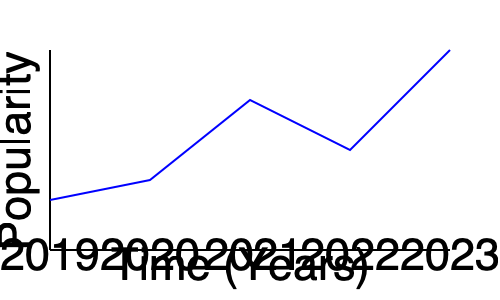Based on the line graph showing the trend of running-related article popularity from 2019 to 2023, which year would be the best time to introduce new types of running stories to broaden the magazine's audience? To determine the best year to introduce new types of running stories, we need to analyze the trend in the graph:

1. 2019 to 2020: There's a slight decrease in popularity.
2. 2020 to 2021: There's a significant increase in popularity.
3. 2021 to 2022: There's a moderate decrease in popularity.
4. 2022 to 2023: There's a sharp increase in popularity, reaching the highest point.

The best time to introduce new types of running stories would be when interest is high but starting to plateau or decline. This allows for capitalizing on the existing interest while providing fresh content to maintain engagement.

In this case, 2021 would be the ideal year because:
1. It follows a period of increased popularity (2020 to 2021).
2. It's just before a decline in interest (2021 to 2022).
3. Introducing new content at this point could help maintain the high interest and prevent the subsequent decline.

While 2023 shows the highest popularity, it might be too late to introduce new content types as the trend is already at its peak. Introducing new stories in 2021 would help maintain audience interest and potentially prevent the decline seen in 2022.
Answer: 2021 